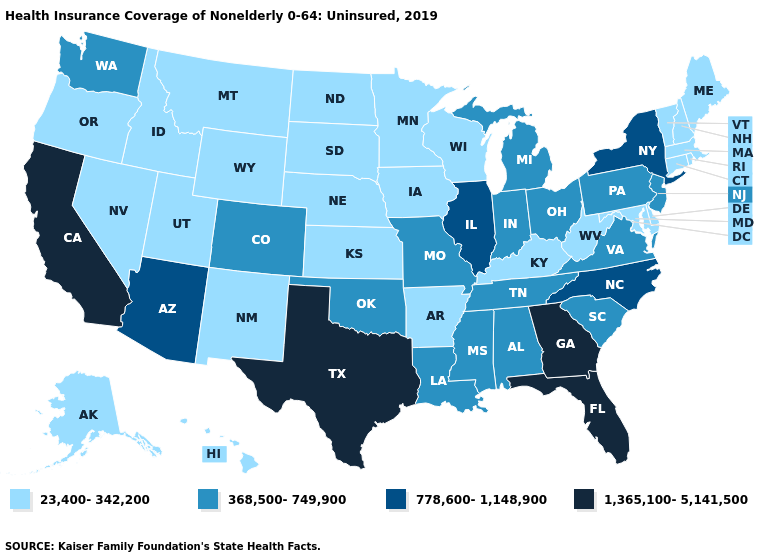What is the lowest value in the USA?
Answer briefly. 23,400-342,200. Name the states that have a value in the range 1,365,100-5,141,500?
Answer briefly. California, Florida, Georgia, Texas. What is the value of Connecticut?
Concise answer only. 23,400-342,200. Which states hav the highest value in the Northeast?
Concise answer only. New York. Among the states that border South Carolina , which have the lowest value?
Answer briefly. North Carolina. What is the value of Maine?
Give a very brief answer. 23,400-342,200. Does the map have missing data?
Quick response, please. No. Among the states that border Nevada , does Utah have the highest value?
Concise answer only. No. Name the states that have a value in the range 1,365,100-5,141,500?
Be succinct. California, Florida, Georgia, Texas. Does New Mexico have the highest value in the USA?
Answer briefly. No. What is the value of Nebraska?
Concise answer only. 23,400-342,200. Name the states that have a value in the range 23,400-342,200?
Keep it brief. Alaska, Arkansas, Connecticut, Delaware, Hawaii, Idaho, Iowa, Kansas, Kentucky, Maine, Maryland, Massachusetts, Minnesota, Montana, Nebraska, Nevada, New Hampshire, New Mexico, North Dakota, Oregon, Rhode Island, South Dakota, Utah, Vermont, West Virginia, Wisconsin, Wyoming. What is the value of Washington?
Quick response, please. 368,500-749,900. Does the map have missing data?
Answer briefly. No. 